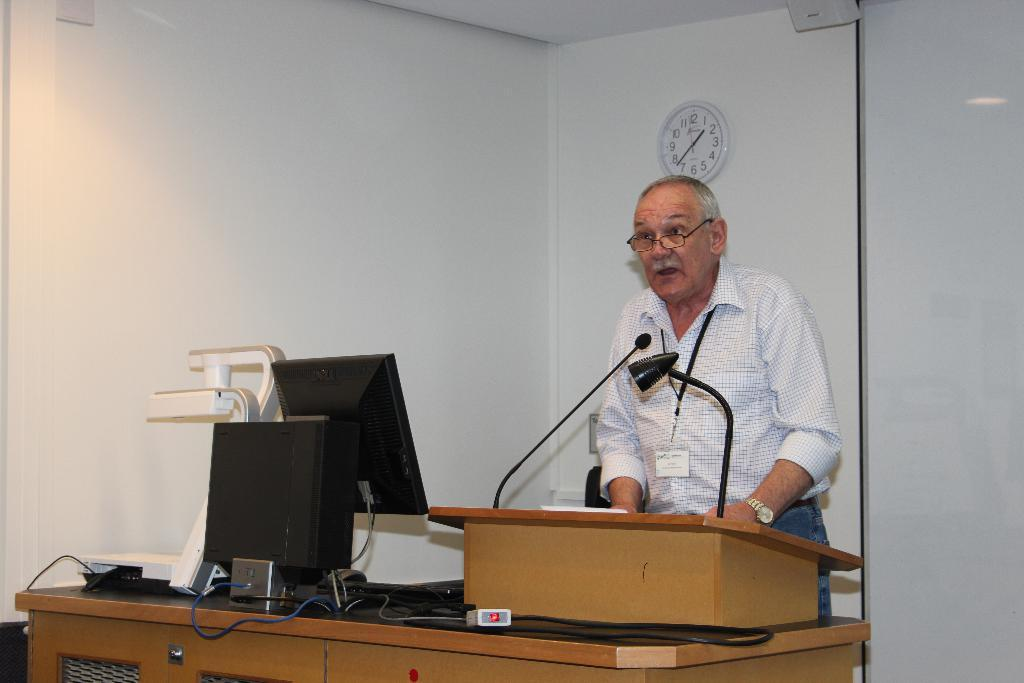What is the main subject of the image? There is a person in the image. What is the person doing in the image? The person is standing in the image. Where is the person located in relation to the desk? The person is in front of a desk in the image. What can be seen on the desk in the image? There is a system (computer or electronic device) and a microphone (mic) on the desk in the image. What type of pen is the robin holding in the image? There is no robin or pen present in the image. 